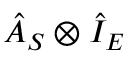<formula> <loc_0><loc_0><loc_500><loc_500>\hat { A } _ { S } \otimes \hat { I } _ { E }</formula> 